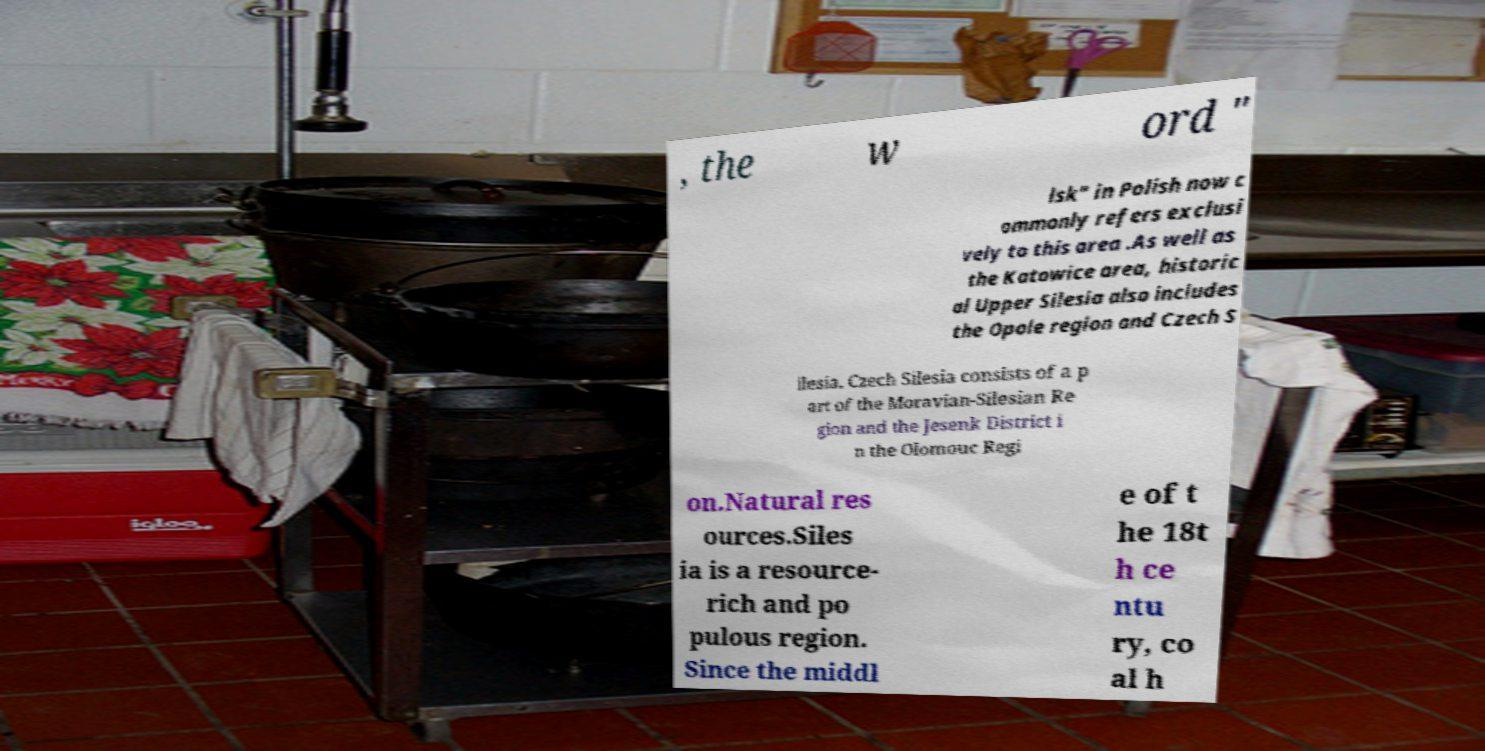Could you extract and type out the text from this image? , the w ord " lsk" in Polish now c ommonly refers exclusi vely to this area .As well as the Katowice area, historic al Upper Silesia also includes the Opole region and Czech S ilesia. Czech Silesia consists of a p art of the Moravian-Silesian Re gion and the Jesenk District i n the Olomouc Regi on.Natural res ources.Siles ia is a resource- rich and po pulous region. Since the middl e of t he 18t h ce ntu ry, co al h 